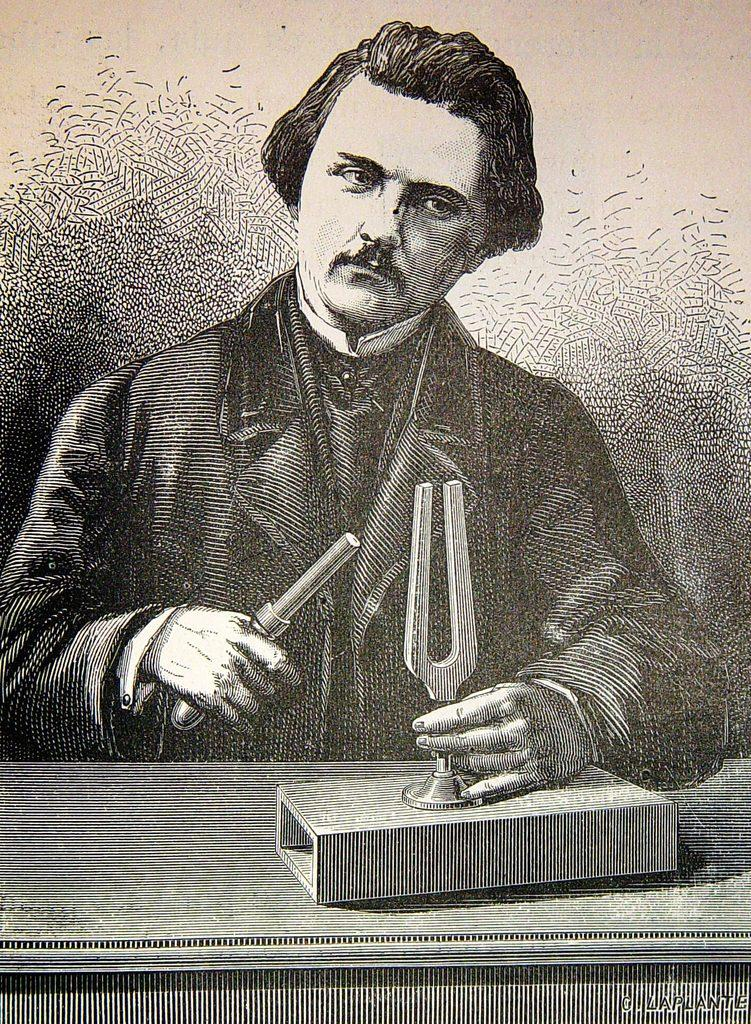What is depicted in the image? The image is a sketch of a person. What is the person doing in the sketch? The person is holding objects. Can you describe the setting of the sketch? There is a table in the image. Is there any text present in the image? Yes, there is text in the bottom right corner of the image. Is there a monkey with a wound on the sidewalk in the image? No, there is no monkey or wound on the sidewalk in the image. The image is a sketch of a person holding objects and standing near a table. 